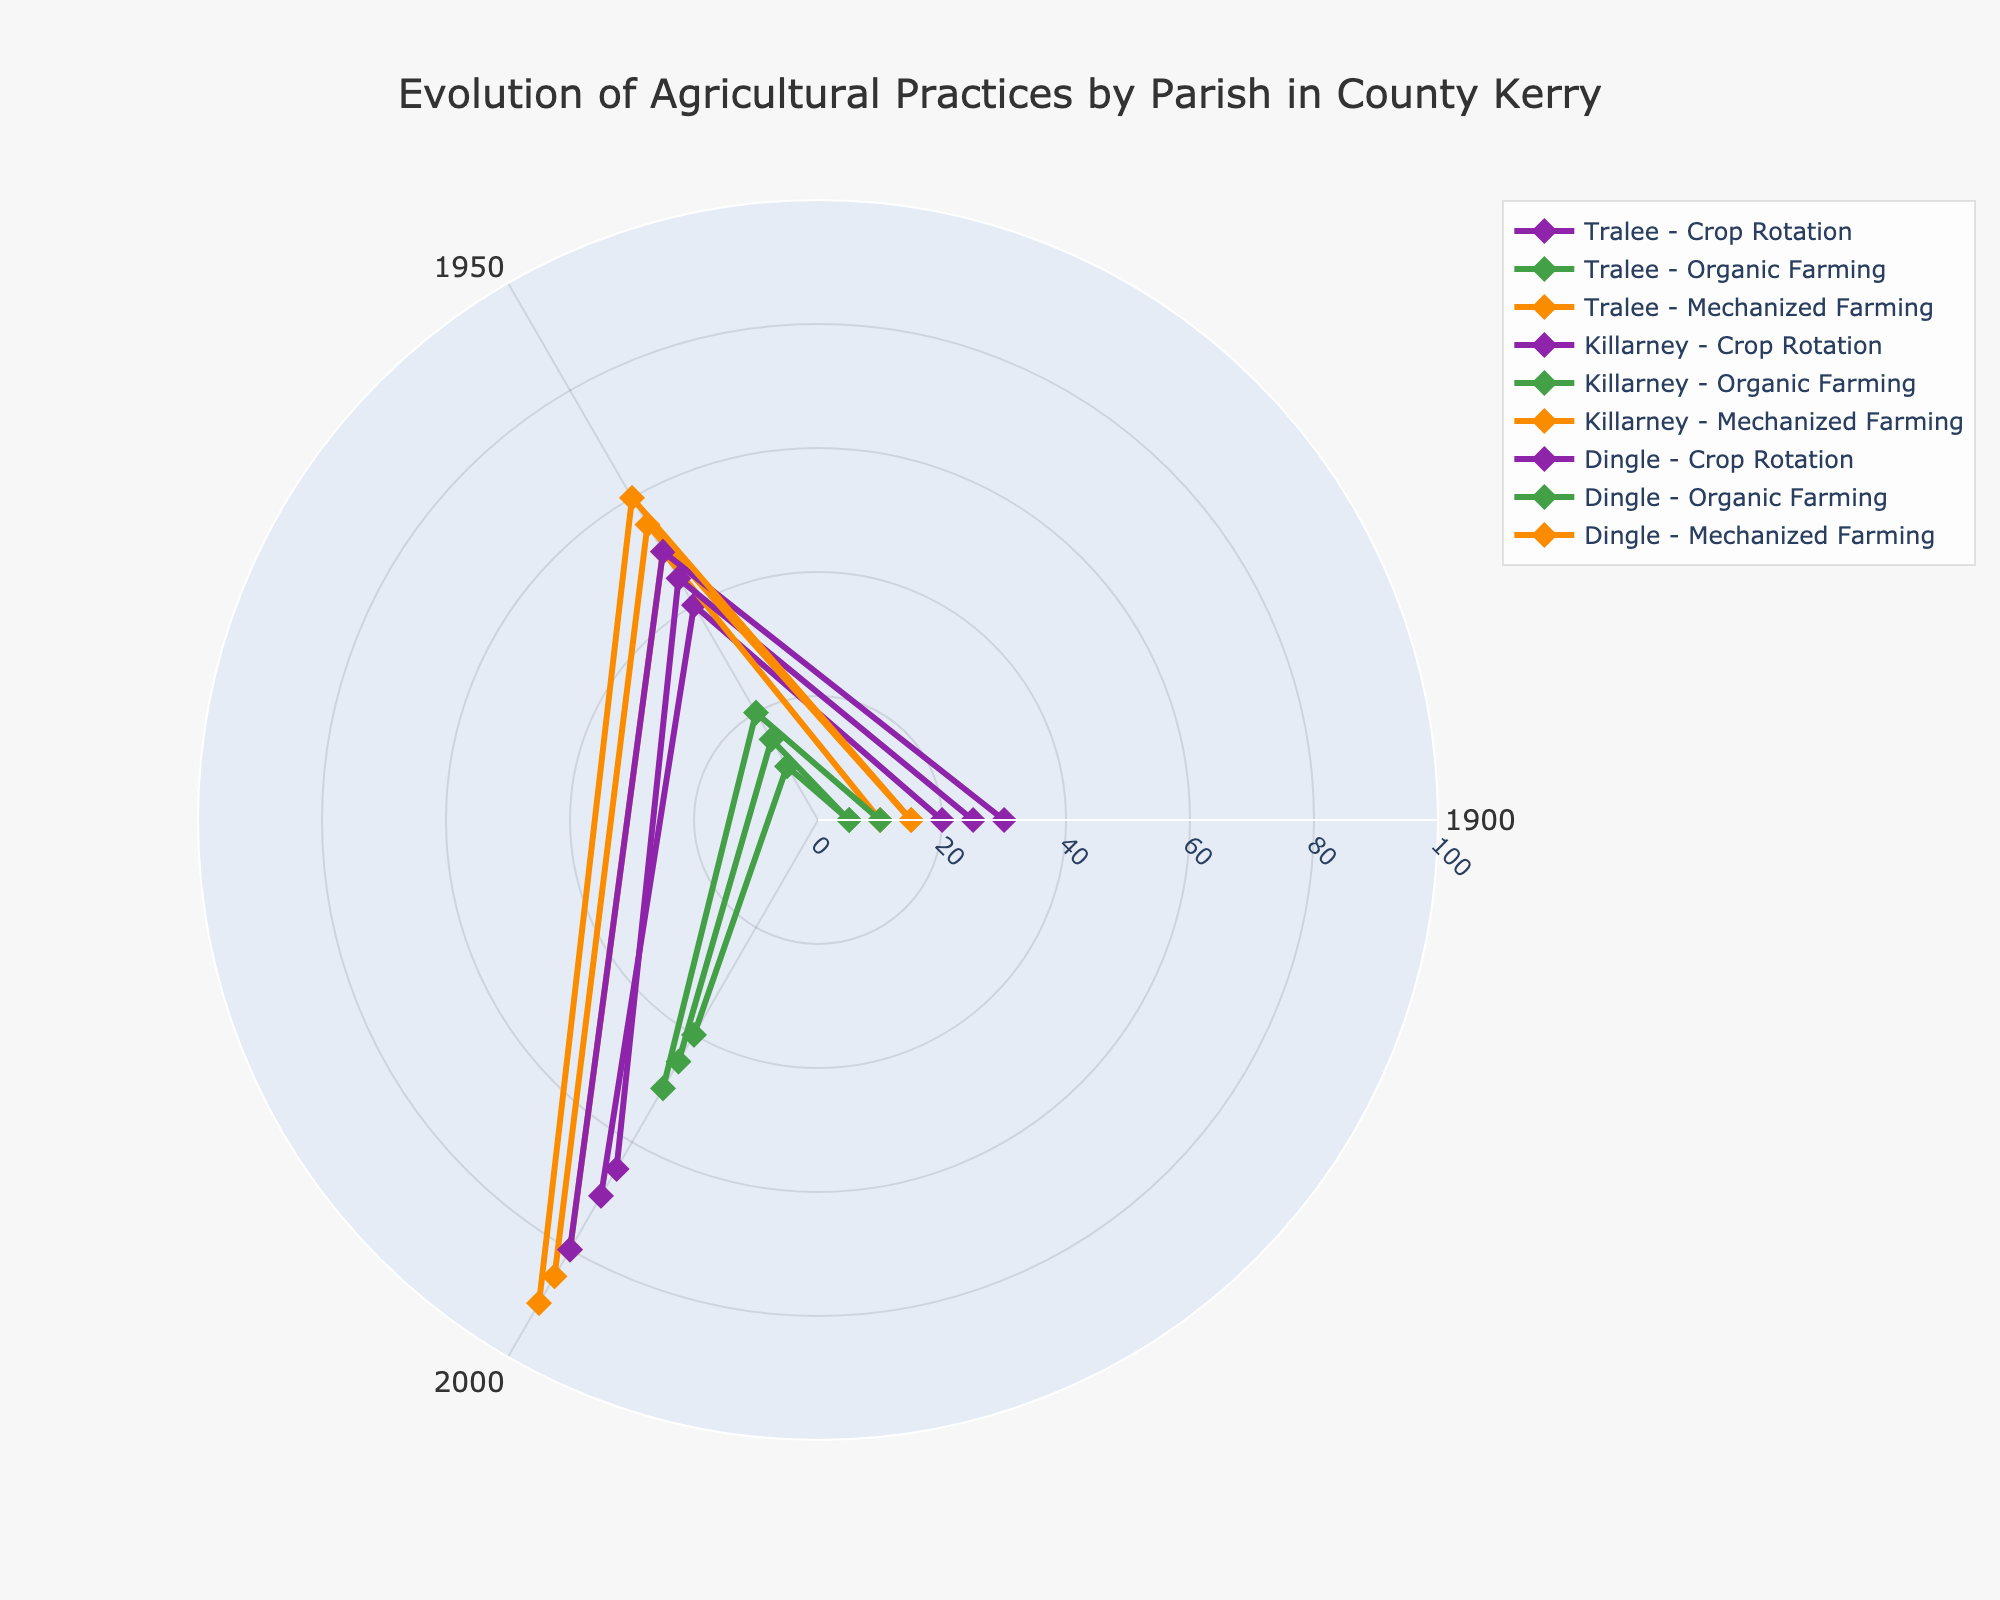What is the title of the figure? The title is usually at the top of a figure. It provides a brief description of what the figure represents. At the top, it states "Evolution of Agricultural Practices by Parish in County Kerry."
Answer: Evolution of Agricultural Practices by Parish in County Kerry Which agricultural practice in Dingle had the highest percentage adoption in 2000? To find this, look for the lines representing Dingle in 2000 and check which of the practices has the highest value on the radial axis. In 2000, the Dingle trace for Mechanized Farming is the highest among the practices.
Answer: Mechanized Farming How did the adoption of Crop Rotation in Killarney change from 1900 to 2000? To determine this, look at the line representing Killarney - Crop Rotation and compare the points at 1900 and 2000. The adoption of Crop Rotation in Killarney increased from 25% in 1900 to 65% in 2000.
Answer: Increased from 25% to 65% Which parish showed the steepest increase in adoption of Mechanized Farming between 1900 and 2000? Compare the slopes of the lines representing Mechanized Farming for each parish from 1900 to 2000. Calculate the differences in adoption percentages for Tralee, Killarney, and Dingle. Dingle showed the steepest increase, from 15% to 90%.
Answer: Dingle What can you infer about the trend of Organic Farming adoption in Tralee over time? Observe the line representing Tralee - Organic Farming. It illustrates a gradual increase from 5% in 1900 to 40% in 2000, indicating a consistent upward trend.
Answer: Gradual increase In which year did Killarney surpass Tralee in adoption of Mechanized Farming? Look at the years along the angular axis and compare the Mechanized Farming lines for Killarney and Tralee. Killarney surpassed Tralee between 1900 and 1950, as Killarney had 55% and Tralee 50% in 1950.
Answer: 1950 What is the average adoption of Organic Farming across all parishes in 1950? Find the adoption rates of Organic Farming in 1950 for Tralee, Killarney, and Dingle. The values are 10%, 15%, and 20%. Average them: (10 + 15 + 20) / 3 = 15
Answer: 15% Which agricultural practice has the least variation in adoption percentages across all parishes in 2000? Compare the adoption percentages in 2000 across all parishes for each practice. Mechanized Farming: [80, 85, 90], Crop Rotation: [70, 65, 80], Organic Farming: [40, 45, 50]. Mechanized Farming has the least variation.
Answer: Mechanized Farming Which parish had the lowest adoption of Crop Rotation in 1900? Look for the points in 1900 for Crop Rotation across all parishes. Check the labels for 1900 and compare. Tralee has the lowest adoption at 20%.
Answer: Tralee 